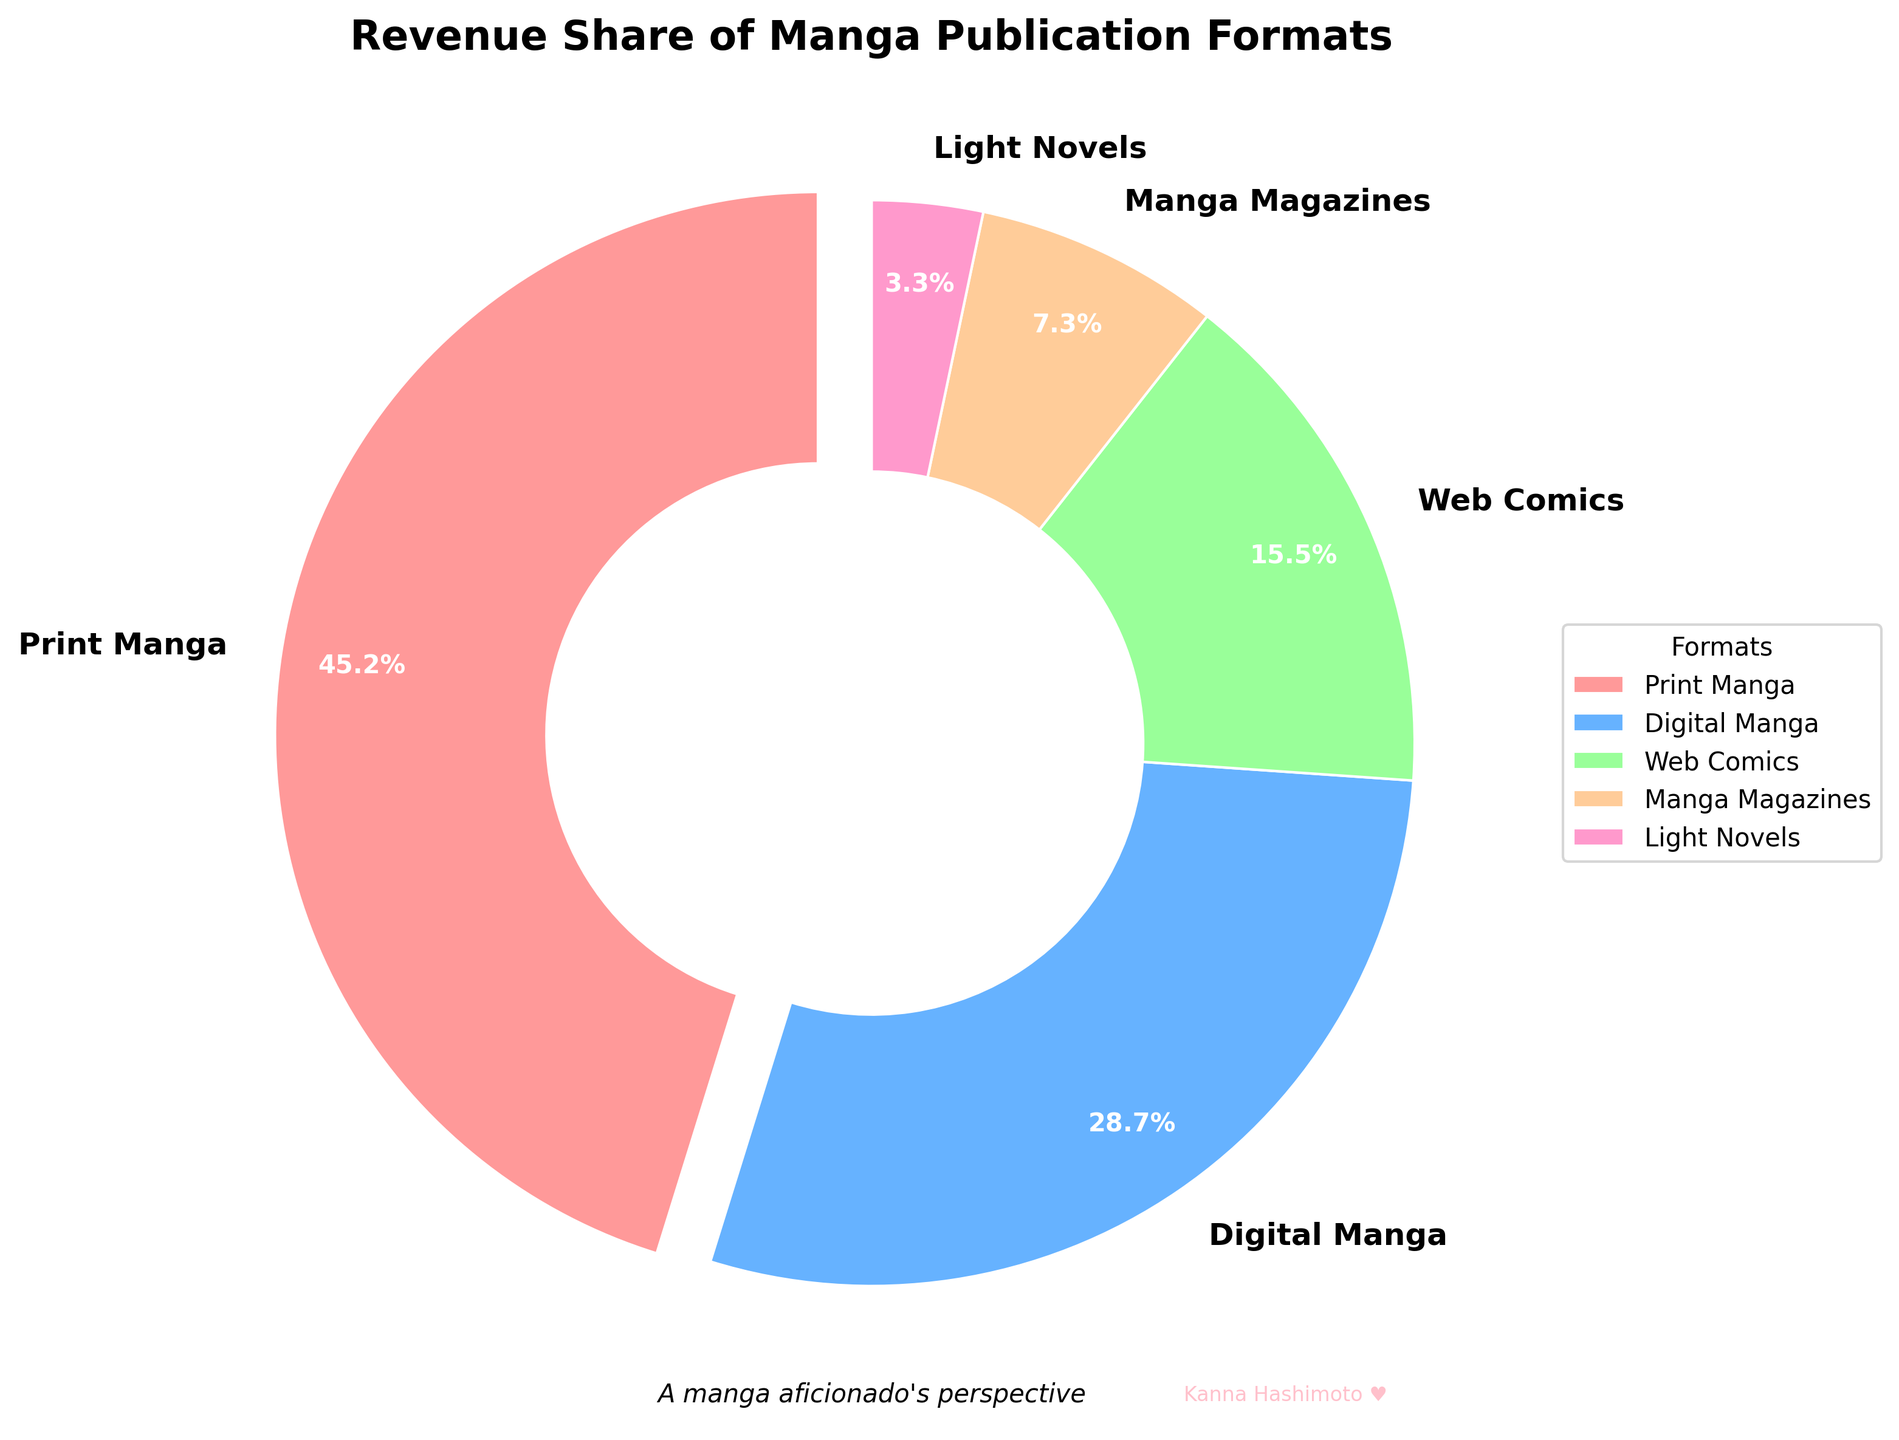What's the largest revenue share format? The figure shows multiple formats with their respective revenue shares. By observing the pie chart, the largest wedge corresponds to "Print Manga" at 45.2%.
Answer: Print Manga Which format has the smallest revenue share? By looking at the smallest wedge in the pie chart, "Light Novels" stand out with a revenue share of 3.3%.
Answer: Light Novels How much more revenue does Digital Manga generate compared to Web Comics? The wedge for Digital Manga is labeled at 28.7%, and Web Comics at 15.5%. The difference is 28.7% - 15.5% = 13.2%.
Answer: 13.2% What is the combined revenue share of Digital Manga and Web Comics? Adding the revenue shares of Digital Manga (28.7%) and Web Comics (15.5%) gives 28.7 + 15.5 = 44.2%.
Answer: 44.2% Which format has a revenue share closest to 10%? Observing the pie chart, Manga Magazines have a share of 7.3%, which is closest to 10%.
Answer: Manga Magazines Rank the formats in descending order of their revenue share. By reading the values on the pie chart wedges, the descending order is: Print Manga (45.2%), Digital Manga (28.7%), Web Comics (15.5%), Manga Magazines (7.3%), and Light Novels (3.3%).
Answer: Print Manga, Digital Manga, Web Comics, Manga Magazines, Light Novels How much more revenue does Print Manga generate compared to the total of Manga Magazines and Light Novels? The revenue shares are Print Manga (45.2%), Manga Magazines (7.3%), and Light Novels (3.3%). The combined share of Manga Magazines and Light Novels is 7.3 + 3.3 = 10.6%. The difference is 45.2% - 10.6% = 34.6%.
Answer: 34.6% Which format is represented by a pink wedge? By observing the pie chart, one can see that the pink wedge is associated with Light Novels, which have a 3.3% revenue share.
Answer: Light Novels 